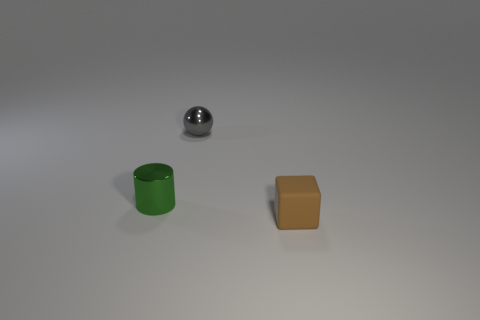What material is the green cylinder?
Keep it short and to the point. Metal. There is a shiny thing that is to the left of the gray object; what is its size?
Your answer should be very brief. Small. Are there any other things that are the same color as the small rubber block?
Give a very brief answer. No. Is there a brown object that is to the right of the shiny object in front of the small metal thing behind the small cylinder?
Keep it short and to the point. Yes. Does the small thing that is to the left of the sphere have the same color as the tiny metal sphere?
Provide a short and direct response. No. What number of blocks are either small gray objects or small metallic things?
Provide a succinct answer. 0. What is the shape of the metallic object that is left of the metal object that is behind the metal cylinder?
Keep it short and to the point. Cylinder. There is a metallic thing that is in front of the small object that is behind the small metal thing on the left side of the gray metal ball; how big is it?
Keep it short and to the point. Small. Do the brown thing and the gray metal sphere have the same size?
Keep it short and to the point. Yes. What number of things are either blue blocks or matte objects?
Provide a short and direct response. 1. 